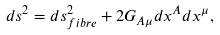Convert formula to latex. <formula><loc_0><loc_0><loc_500><loc_500>d s ^ { 2 } = d s ^ { 2 } _ { f i b r e } + 2 G _ { A \mu } d x ^ { A } d x ^ { \mu } ,</formula> 